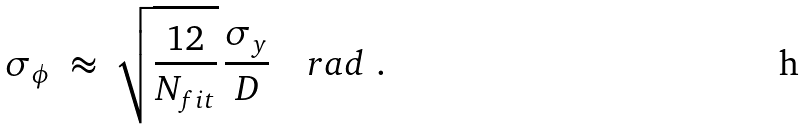Convert formula to latex. <formula><loc_0><loc_0><loc_500><loc_500>\sigma _ { \phi } \ \approx \ \sqrt { \frac { 1 2 } { N _ { f i t } } } \, \frac { \sigma _ { y } } { D } \quad r a d \ .</formula> 